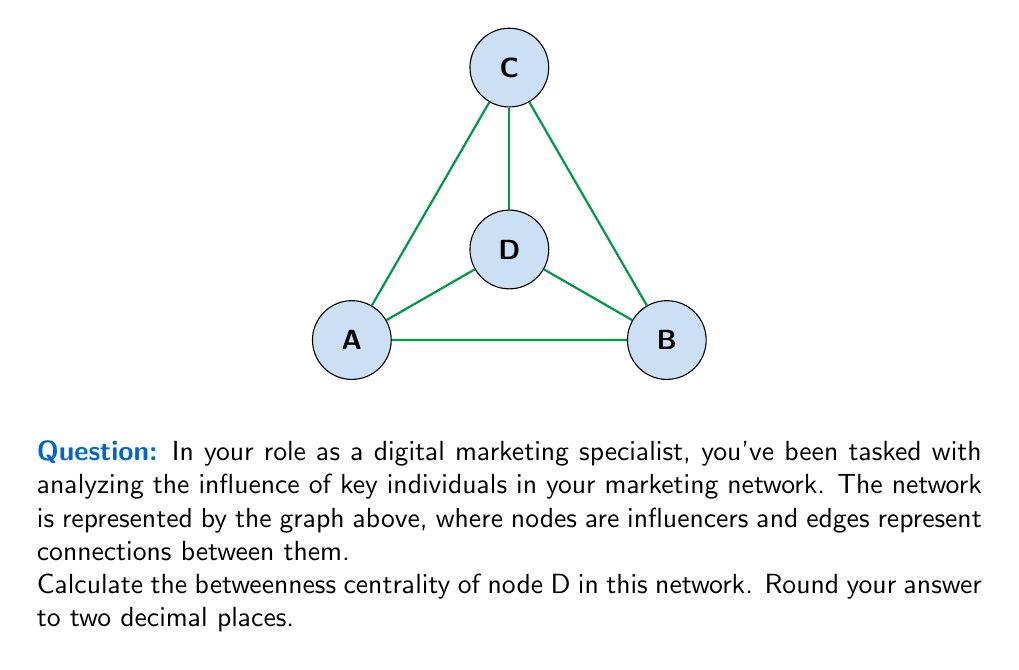Can you answer this question? To calculate the betweenness centrality of node D, we need to follow these steps:

1) First, recall that betweenness centrality is calculated as:

   $$C_B(v) = \sum_{s \neq v \neq t} \frac{\sigma_{st}(v)}{\sigma_{st}}$$

   where $\sigma_{st}$ is the total number of shortest paths from node s to node t, and $\sigma_{st}(v)$ is the number of those paths that pass through v.

2) In this network, we need to consider all pairs of nodes excluding D:
   (A,B), (A,C), (B,C)

3) For each pair, we count the total number of shortest paths and how many pass through D:

   A to B: 2 shortest paths (A-B and A-D-B), 1 through D
   A to C: 2 shortest paths (A-C and A-D-C), 1 through D
   B to C: 2 shortest paths (B-C and B-D-C), 1 through D

4) Now we can calculate:

   $$C_B(D) = \frac{1}{2} + \frac{1}{2} + \frac{1}{2} = 1.5$$

5) To normalize this, we divide by the maximum possible betweenness centrality in a network with 4 nodes, which is $(n-1)(n-2)/2 = (3)(2)/2 = 3$:

   $$C'_B(D) = \frac{1.5}{3} = 0.5$$

6) Rounding to two decimal places gives us 0.50.
Answer: 0.50 